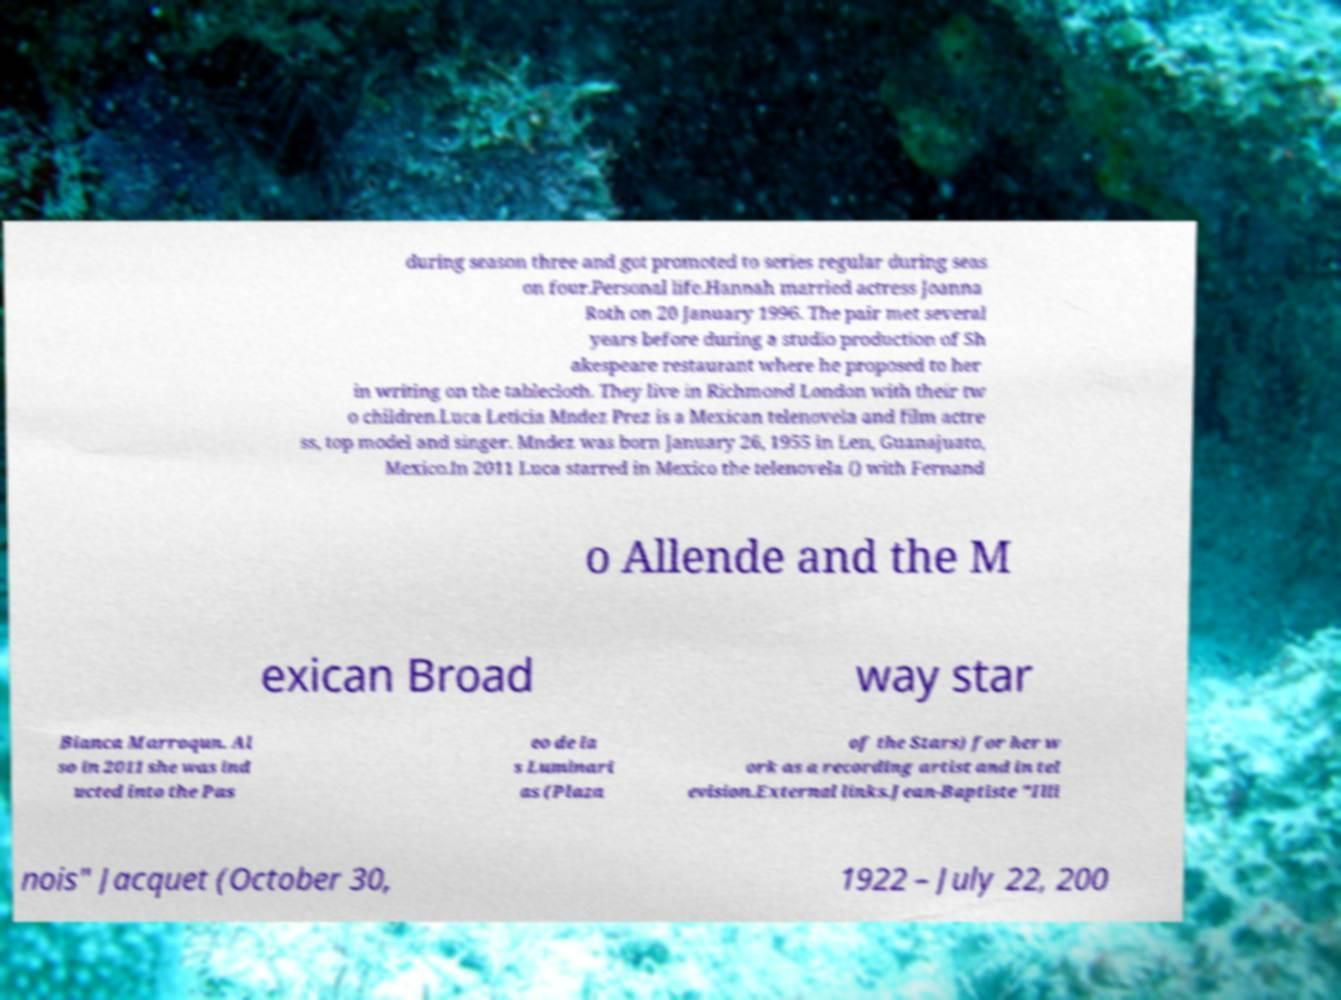Please read and relay the text visible in this image. What does it say? during season three and got promoted to series regular during seas on four.Personal life.Hannah married actress Joanna Roth on 20 January 1996. The pair met several years before during a studio production of Sh akespeare restaurant where he proposed to her in writing on the tablecloth. They live in Richmond London with their tw o children.Luca Leticia Mndez Prez is a Mexican telenovela and film actre ss, top model and singer. Mndez was born January 26, 1955 in Len, Guanajuato, Mexico.In 2011 Luca starred in Mexico the telenovela () with Fernand o Allende and the M exican Broad way star Bianca Marroqun. Al so in 2011 she was ind ucted into the Pas eo de la s Luminari as (Plaza of the Stars) for her w ork as a recording artist and in tel evision.External links.Jean-Baptiste "Illi nois" Jacquet (October 30, 1922 – July 22, 200 